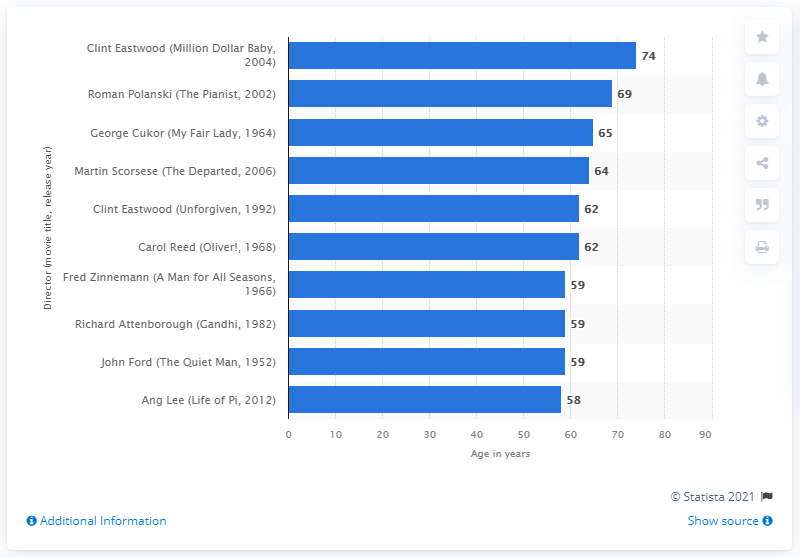Indicate a few pertinent items in this graphic. At the age of 74, Clint Eastwood won his second Best Director award. 